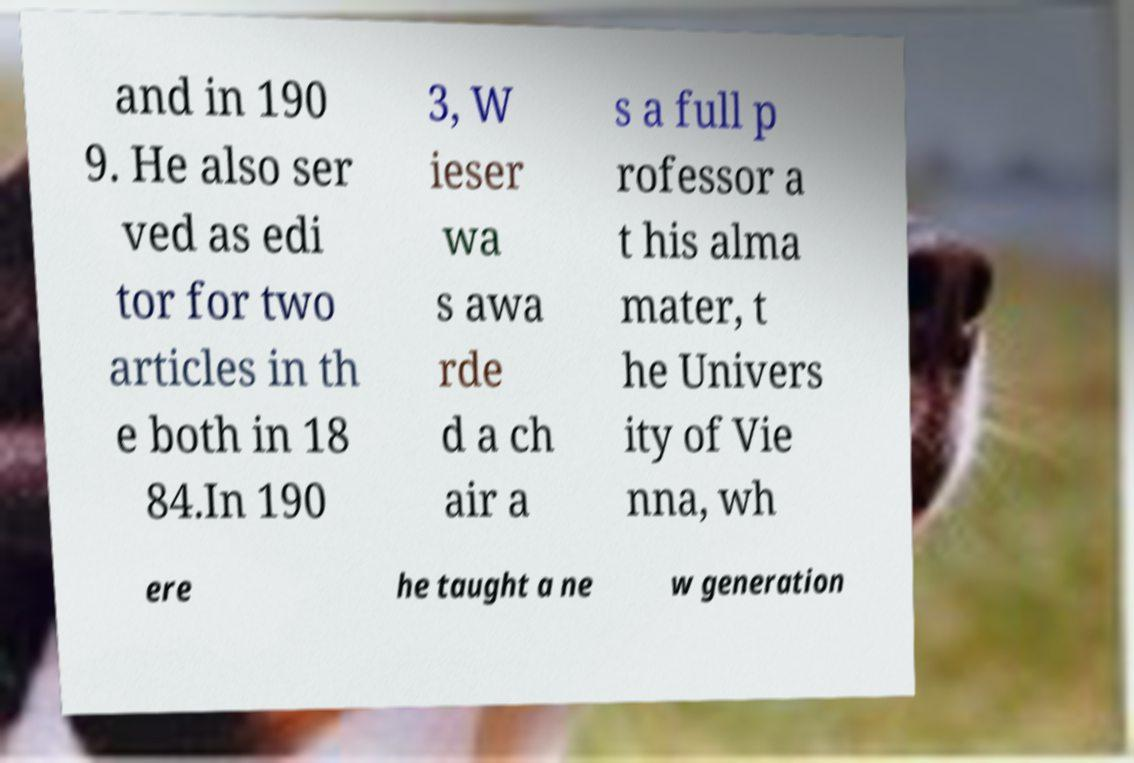There's text embedded in this image that I need extracted. Can you transcribe it verbatim? and in 190 9. He also ser ved as edi tor for two articles in th e both in 18 84.In 190 3, W ieser wa s awa rde d a ch air a s a full p rofessor a t his alma mater, t he Univers ity of Vie nna, wh ere he taught a ne w generation 